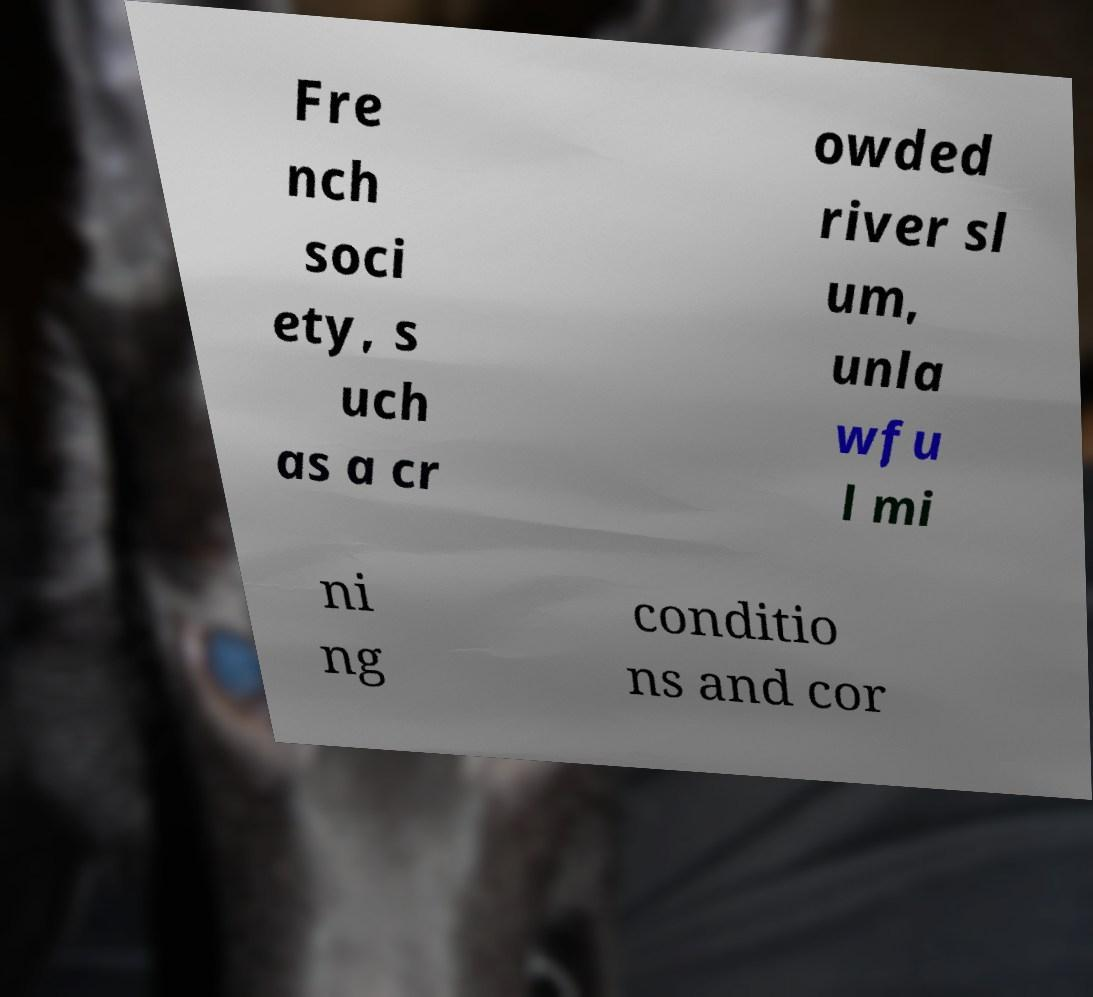Can you read and provide the text displayed in the image?This photo seems to have some interesting text. Can you extract and type it out for me? Fre nch soci ety, s uch as a cr owded river sl um, unla wfu l mi ni ng conditio ns and cor 